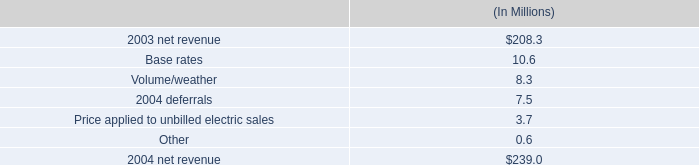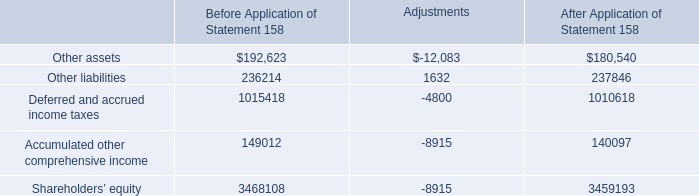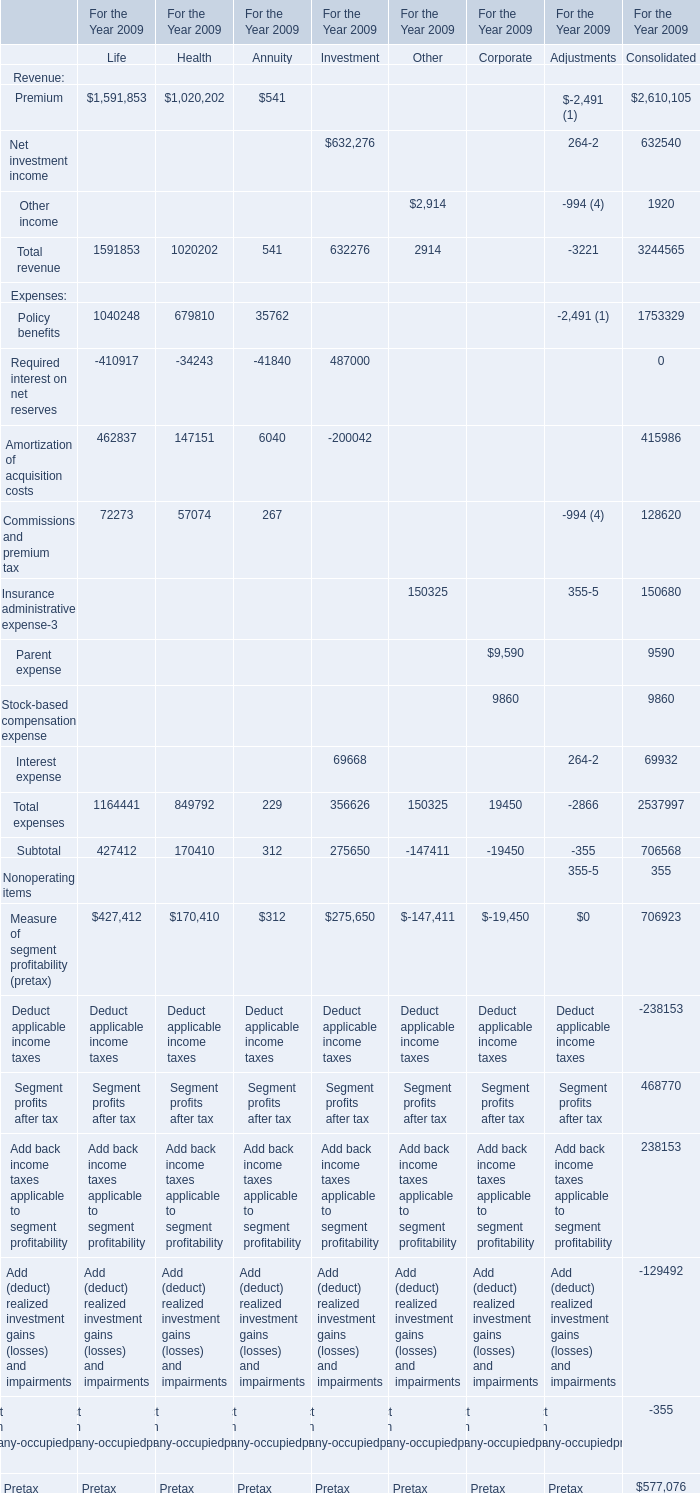What is the average amount of Shareholders’ equity of Before Application of Statement 158, and Premium of For the Year 2009 Consolidated ? 
Computations: ((3468108.0 + 2610105.0) / 2)
Answer: 3039106.5. 